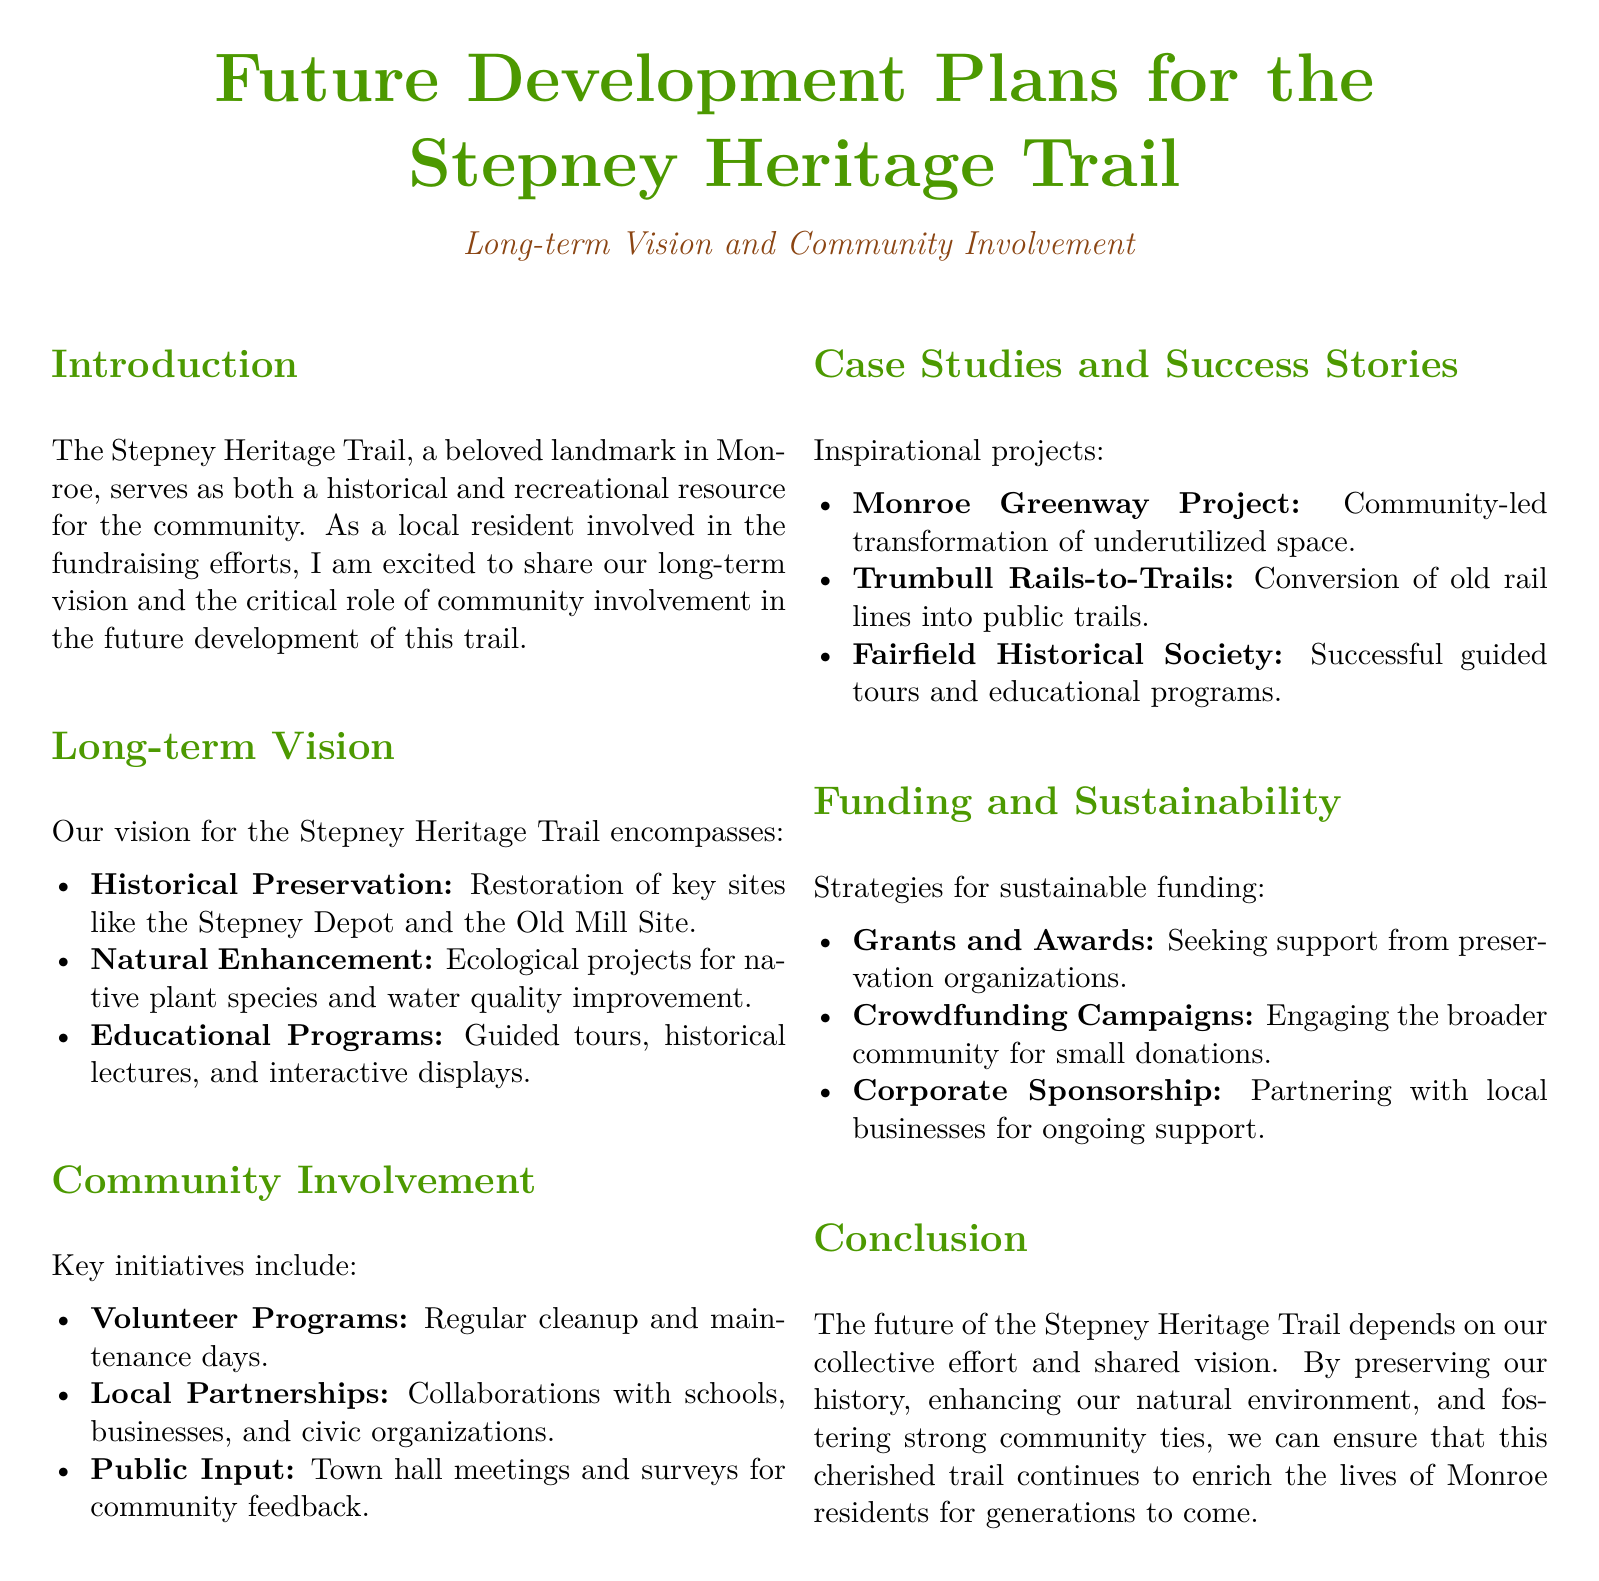What is the main purpose of the Stepney Heritage Trail? The main purpose is to serve as both a historical and recreational resource for the community.
Answer: Historical and recreational resource What are the three components of the long-term vision? The three components are historical preservation, natural enhancement, and educational programs.
Answer: Historical preservation, natural enhancement, educational programs Which project is mentioned as an inspirational case study related to community-led transformation? The Monroe Greenway Project is mentioned as an inspirational case study.
Answer: Monroe Greenway Project How many key initiatives are listed under community involvement? There are three key initiatives listed under community involvement.
Answer: Three What type of funding strategy involves seeking support from preservation organizations? The funding strategy is referred to as grants and awards.
Answer: Grants and awards What is one method used to involve the local community in the Stepney Heritage Trail? One method is conducting town hall meetings for community feedback.
Answer: Town hall meetings Which site is prioritized for restoration in the long-term vision? The Stepney Depot is prioritized for restoration.
Answer: Stepney Depot What ecological project is planned as part of natural enhancement? The planned ecological project focuses on native plant species and water quality improvement.
Answer: Native plant species and water quality improvement What type of businesses are targeted for corporate sponsorship? Local businesses are targeted for corporate sponsorship.
Answer: Local businesses 